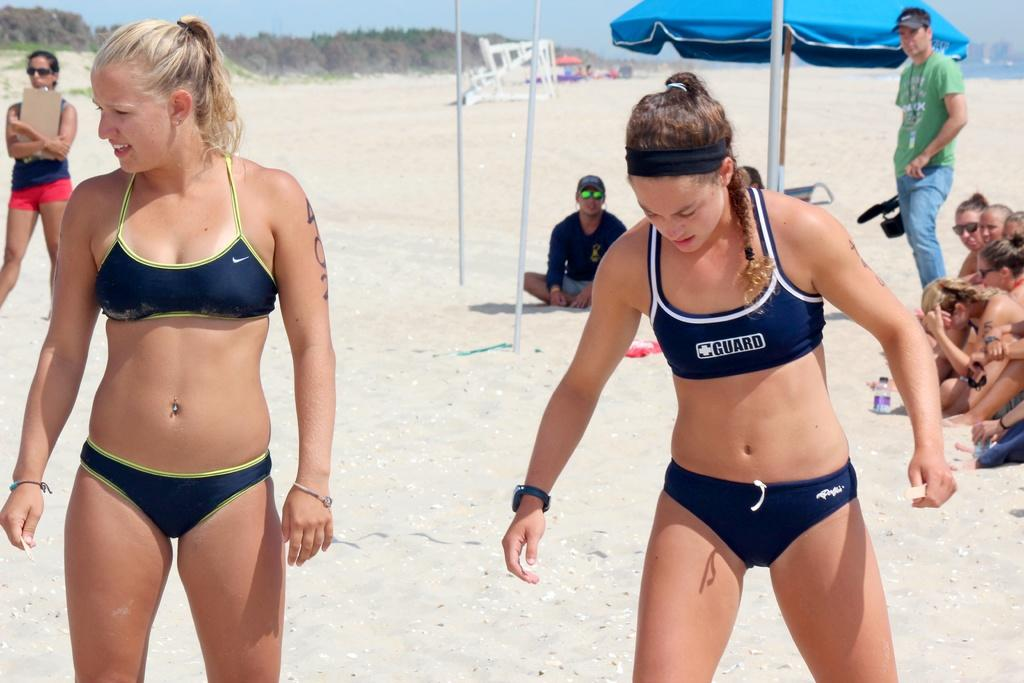<image>
Create a compact narrative representing the image presented. a couple of volleyball players that have guard written on them 